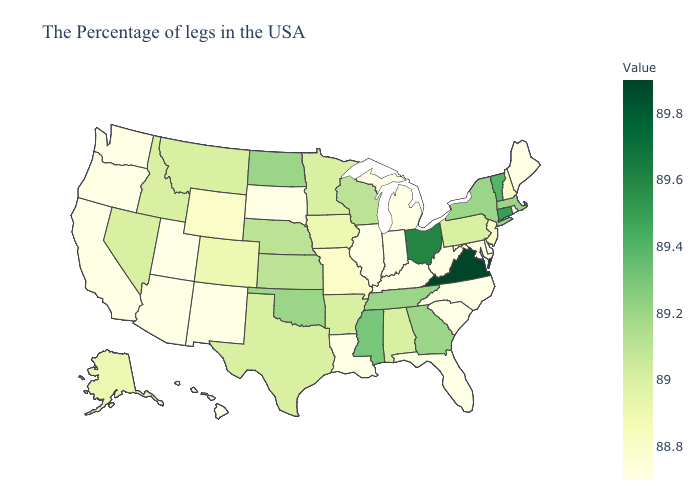Does Delaware have the highest value in the USA?
Keep it brief. No. Among the states that border Iowa , which have the lowest value?
Give a very brief answer. Illinois, South Dakota. 